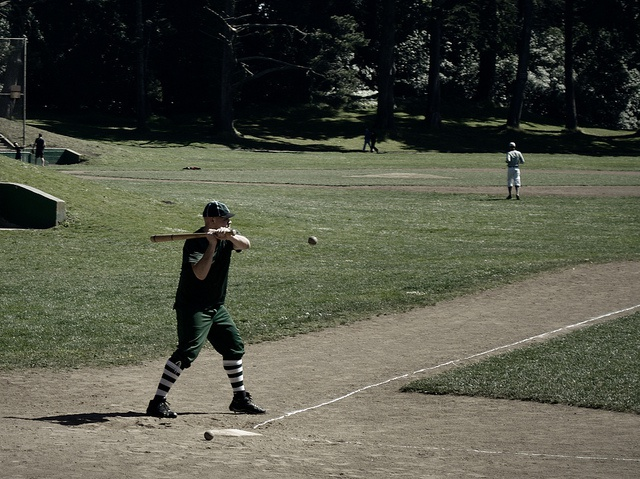Describe the objects in this image and their specific colors. I can see people in black, gray, and darkgray tones, people in black, gray, purple, and darkgray tones, baseball bat in black and gray tones, people in black, gray, and darkgray tones, and people in black, gray, and darkblue tones in this image. 